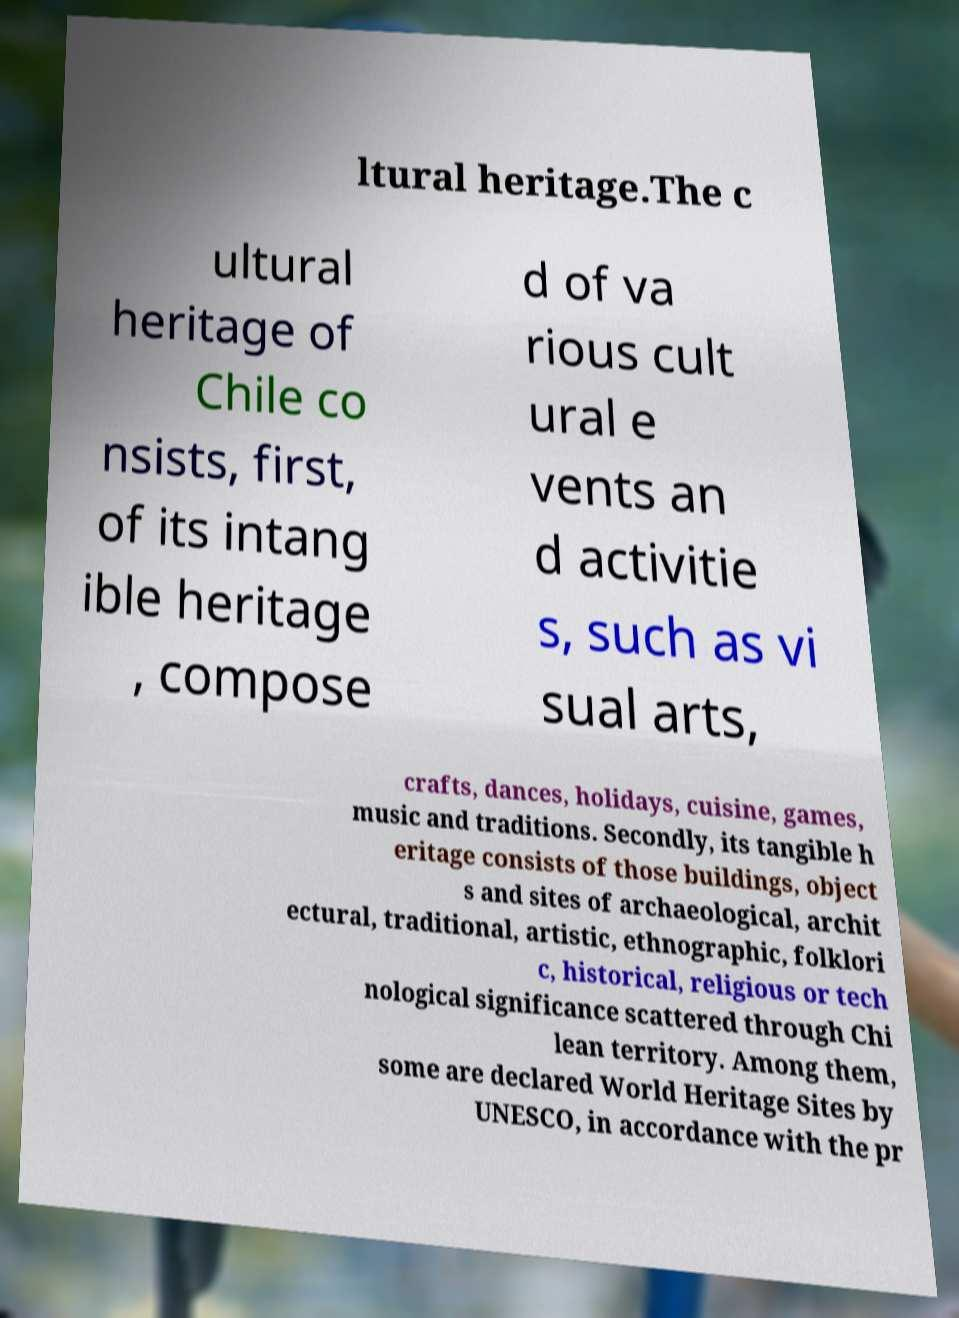What messages or text are displayed in this image? I need them in a readable, typed format. ltural heritage.The c ultural heritage of Chile co nsists, first, of its intang ible heritage , compose d of va rious cult ural e vents an d activitie s, such as vi sual arts, crafts, dances, holidays, cuisine, games, music and traditions. Secondly, its tangible h eritage consists of those buildings, object s and sites of archaeological, archit ectural, traditional, artistic, ethnographic, folklori c, historical, religious or tech nological significance scattered through Chi lean territory. Among them, some are declared World Heritage Sites by UNESCO, in accordance with the pr 